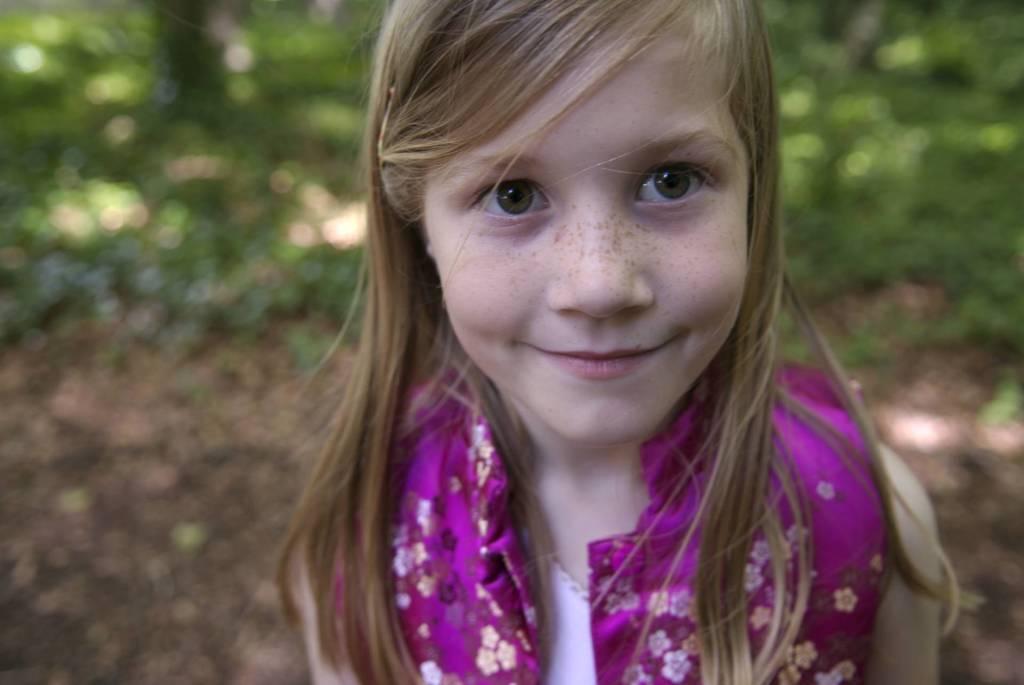Can you describe this image briefly? In this image we can see a girl. On the backside we can see some plants. 